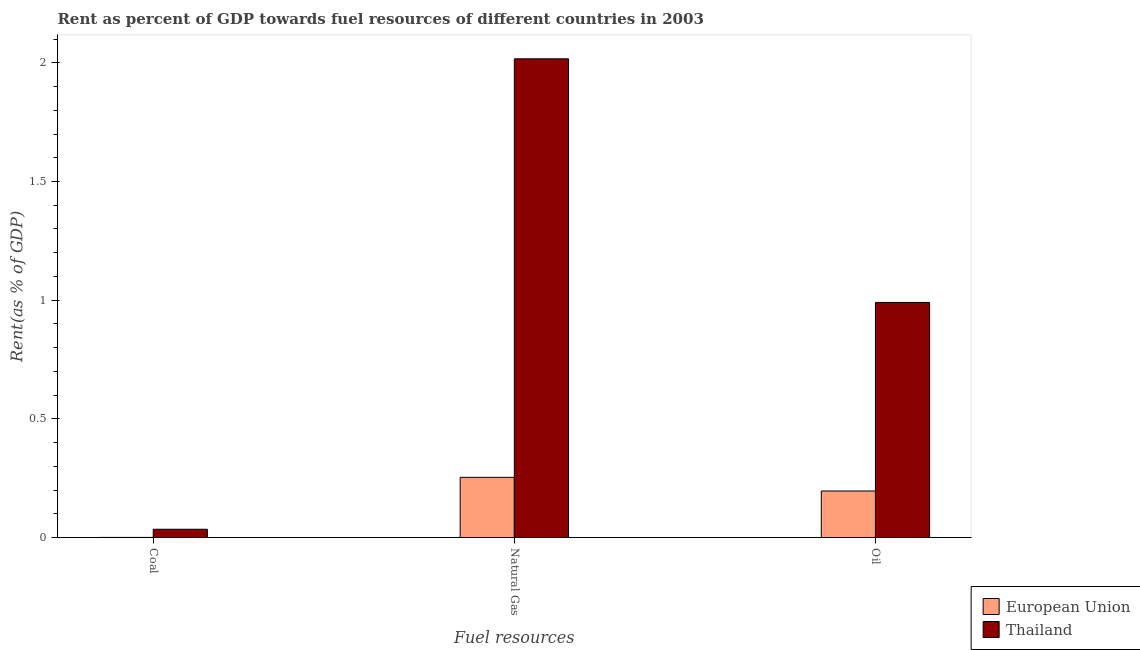How many different coloured bars are there?
Your answer should be compact. 2. How many groups of bars are there?
Ensure brevity in your answer.  3. Are the number of bars per tick equal to the number of legend labels?
Your answer should be compact. Yes. How many bars are there on the 2nd tick from the left?
Your response must be concise. 2. How many bars are there on the 3rd tick from the right?
Your response must be concise. 2. What is the label of the 2nd group of bars from the left?
Ensure brevity in your answer.  Natural Gas. What is the rent towards oil in European Union?
Your answer should be very brief. 0.2. Across all countries, what is the maximum rent towards natural gas?
Offer a terse response. 2.02. Across all countries, what is the minimum rent towards coal?
Offer a very short reply. 0. In which country was the rent towards oil maximum?
Your response must be concise. Thailand. What is the total rent towards oil in the graph?
Your answer should be compact. 1.19. What is the difference between the rent towards coal in European Union and that in Thailand?
Give a very brief answer. -0.03. What is the difference between the rent towards natural gas in Thailand and the rent towards oil in European Union?
Offer a terse response. 1.82. What is the average rent towards coal per country?
Your answer should be compact. 0.02. What is the difference between the rent towards oil and rent towards natural gas in European Union?
Your response must be concise. -0.06. What is the ratio of the rent towards oil in Thailand to that in European Union?
Keep it short and to the point. 5.05. Is the rent towards coal in European Union less than that in Thailand?
Offer a very short reply. Yes. What is the difference between the highest and the second highest rent towards oil?
Offer a terse response. 0.79. What is the difference between the highest and the lowest rent towards oil?
Your answer should be compact. 0.79. What does the 1st bar from the left in Coal represents?
Offer a terse response. European Union. Is it the case that in every country, the sum of the rent towards coal and rent towards natural gas is greater than the rent towards oil?
Offer a terse response. Yes. How many countries are there in the graph?
Your answer should be very brief. 2. What is the difference between two consecutive major ticks on the Y-axis?
Ensure brevity in your answer.  0.5. Are the values on the major ticks of Y-axis written in scientific E-notation?
Give a very brief answer. No. Does the graph contain grids?
Keep it short and to the point. No. Where does the legend appear in the graph?
Make the answer very short. Bottom right. How many legend labels are there?
Your response must be concise. 2. What is the title of the graph?
Your response must be concise. Rent as percent of GDP towards fuel resources of different countries in 2003. What is the label or title of the X-axis?
Your answer should be very brief. Fuel resources. What is the label or title of the Y-axis?
Your answer should be very brief. Rent(as % of GDP). What is the Rent(as % of GDP) of European Union in Coal?
Give a very brief answer. 0. What is the Rent(as % of GDP) in Thailand in Coal?
Provide a succinct answer. 0.03. What is the Rent(as % of GDP) of European Union in Natural Gas?
Your response must be concise. 0.25. What is the Rent(as % of GDP) in Thailand in Natural Gas?
Your answer should be compact. 2.02. What is the Rent(as % of GDP) of European Union in Oil?
Offer a terse response. 0.2. What is the Rent(as % of GDP) in Thailand in Oil?
Keep it short and to the point. 0.99. Across all Fuel resources, what is the maximum Rent(as % of GDP) in European Union?
Offer a very short reply. 0.25. Across all Fuel resources, what is the maximum Rent(as % of GDP) of Thailand?
Provide a short and direct response. 2.02. Across all Fuel resources, what is the minimum Rent(as % of GDP) in European Union?
Make the answer very short. 0. Across all Fuel resources, what is the minimum Rent(as % of GDP) in Thailand?
Provide a succinct answer. 0.03. What is the total Rent(as % of GDP) of European Union in the graph?
Keep it short and to the point. 0.45. What is the total Rent(as % of GDP) in Thailand in the graph?
Keep it short and to the point. 3.04. What is the difference between the Rent(as % of GDP) of European Union in Coal and that in Natural Gas?
Offer a very short reply. -0.25. What is the difference between the Rent(as % of GDP) of Thailand in Coal and that in Natural Gas?
Provide a short and direct response. -1.98. What is the difference between the Rent(as % of GDP) in European Union in Coal and that in Oil?
Make the answer very short. -0.2. What is the difference between the Rent(as % of GDP) in Thailand in Coal and that in Oil?
Your answer should be compact. -0.96. What is the difference between the Rent(as % of GDP) of European Union in Natural Gas and that in Oil?
Offer a terse response. 0.06. What is the difference between the Rent(as % of GDP) of Thailand in Natural Gas and that in Oil?
Provide a short and direct response. 1.03. What is the difference between the Rent(as % of GDP) of European Union in Coal and the Rent(as % of GDP) of Thailand in Natural Gas?
Ensure brevity in your answer.  -2.02. What is the difference between the Rent(as % of GDP) in European Union in Coal and the Rent(as % of GDP) in Thailand in Oil?
Ensure brevity in your answer.  -0.99. What is the difference between the Rent(as % of GDP) in European Union in Natural Gas and the Rent(as % of GDP) in Thailand in Oil?
Your response must be concise. -0.74. What is the average Rent(as % of GDP) of European Union per Fuel resources?
Your answer should be compact. 0.15. What is the difference between the Rent(as % of GDP) in European Union and Rent(as % of GDP) in Thailand in Coal?
Make the answer very short. -0.03. What is the difference between the Rent(as % of GDP) in European Union and Rent(as % of GDP) in Thailand in Natural Gas?
Give a very brief answer. -1.76. What is the difference between the Rent(as % of GDP) in European Union and Rent(as % of GDP) in Thailand in Oil?
Make the answer very short. -0.79. What is the ratio of the Rent(as % of GDP) in Thailand in Coal to that in Natural Gas?
Make the answer very short. 0.02. What is the ratio of the Rent(as % of GDP) in European Union in Coal to that in Oil?
Offer a terse response. 0. What is the ratio of the Rent(as % of GDP) in Thailand in Coal to that in Oil?
Offer a very short reply. 0.04. What is the ratio of the Rent(as % of GDP) in European Union in Natural Gas to that in Oil?
Provide a short and direct response. 1.29. What is the ratio of the Rent(as % of GDP) in Thailand in Natural Gas to that in Oil?
Provide a short and direct response. 2.04. What is the difference between the highest and the second highest Rent(as % of GDP) of European Union?
Give a very brief answer. 0.06. What is the difference between the highest and the second highest Rent(as % of GDP) of Thailand?
Give a very brief answer. 1.03. What is the difference between the highest and the lowest Rent(as % of GDP) of European Union?
Keep it short and to the point. 0.25. What is the difference between the highest and the lowest Rent(as % of GDP) in Thailand?
Offer a very short reply. 1.98. 